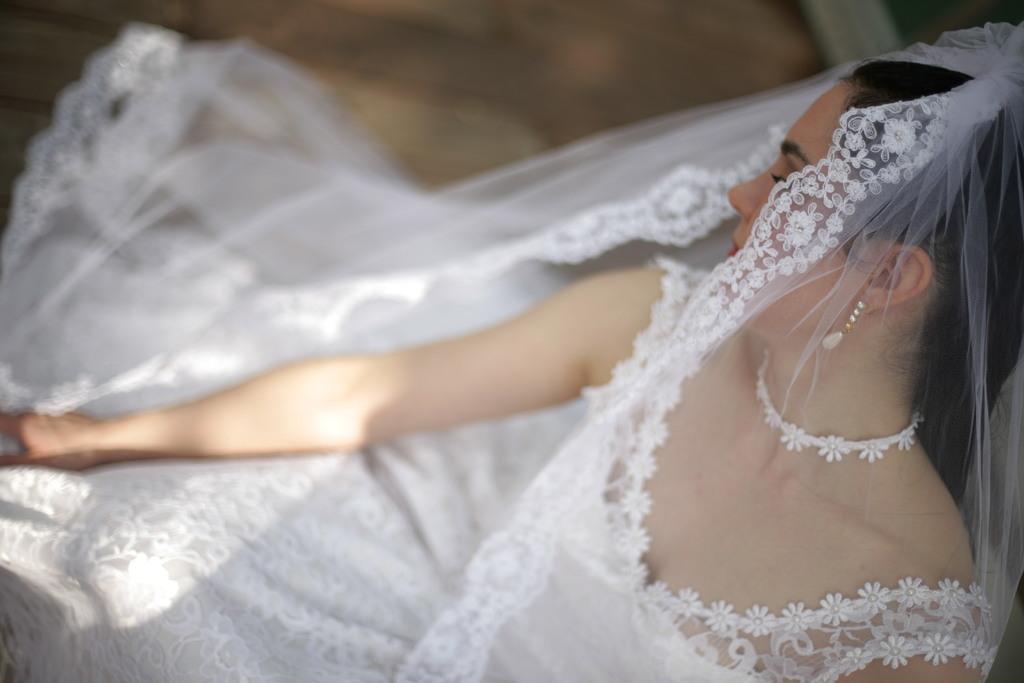Please provide a concise description of this image. In this image, we can see a woman wearing a white color dress. 